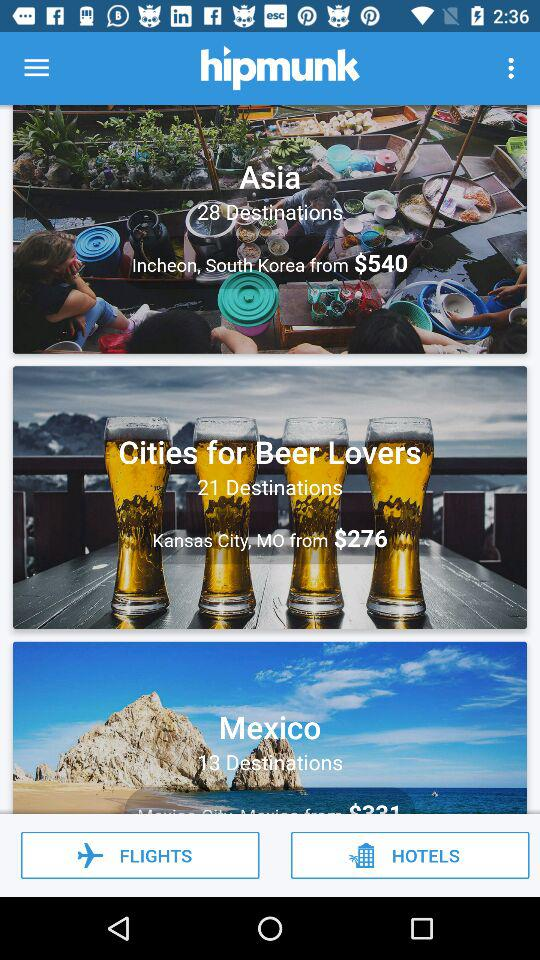How many destinations are offered for Asia?
Answer the question using a single word or phrase. 28 